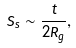<formula> <loc_0><loc_0><loc_500><loc_500>S _ { s } \sim \frac { t } { 2 R _ { g } } ,</formula> 